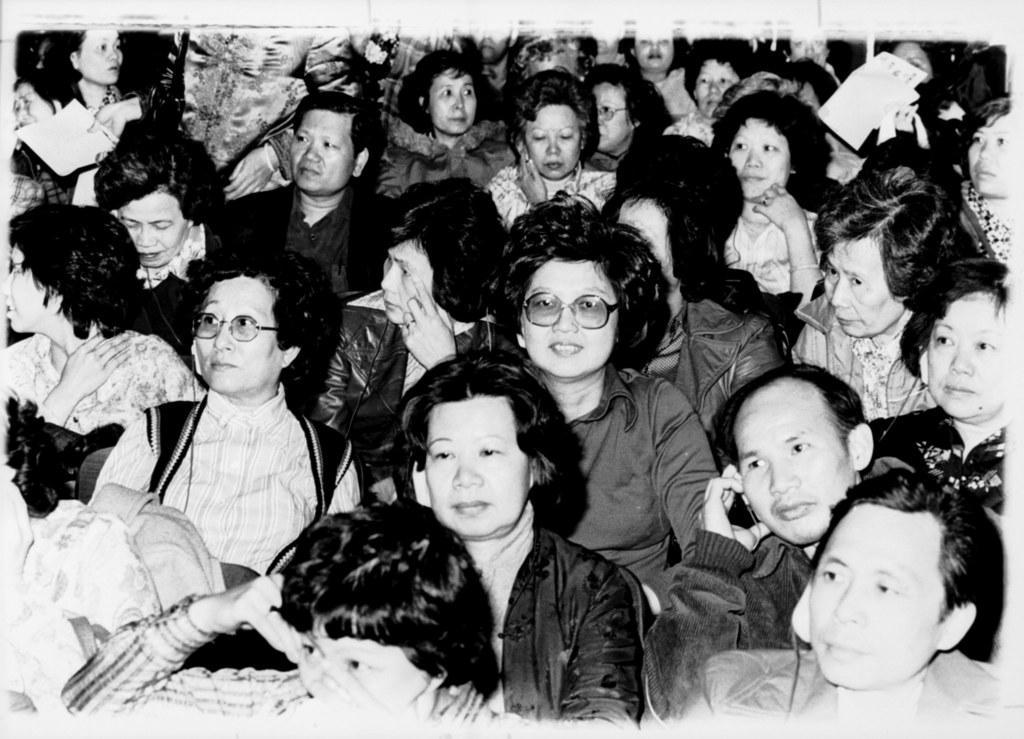How would you summarize this image in a sentence or two? This is a black and white picture. I can see group of people sitting. 